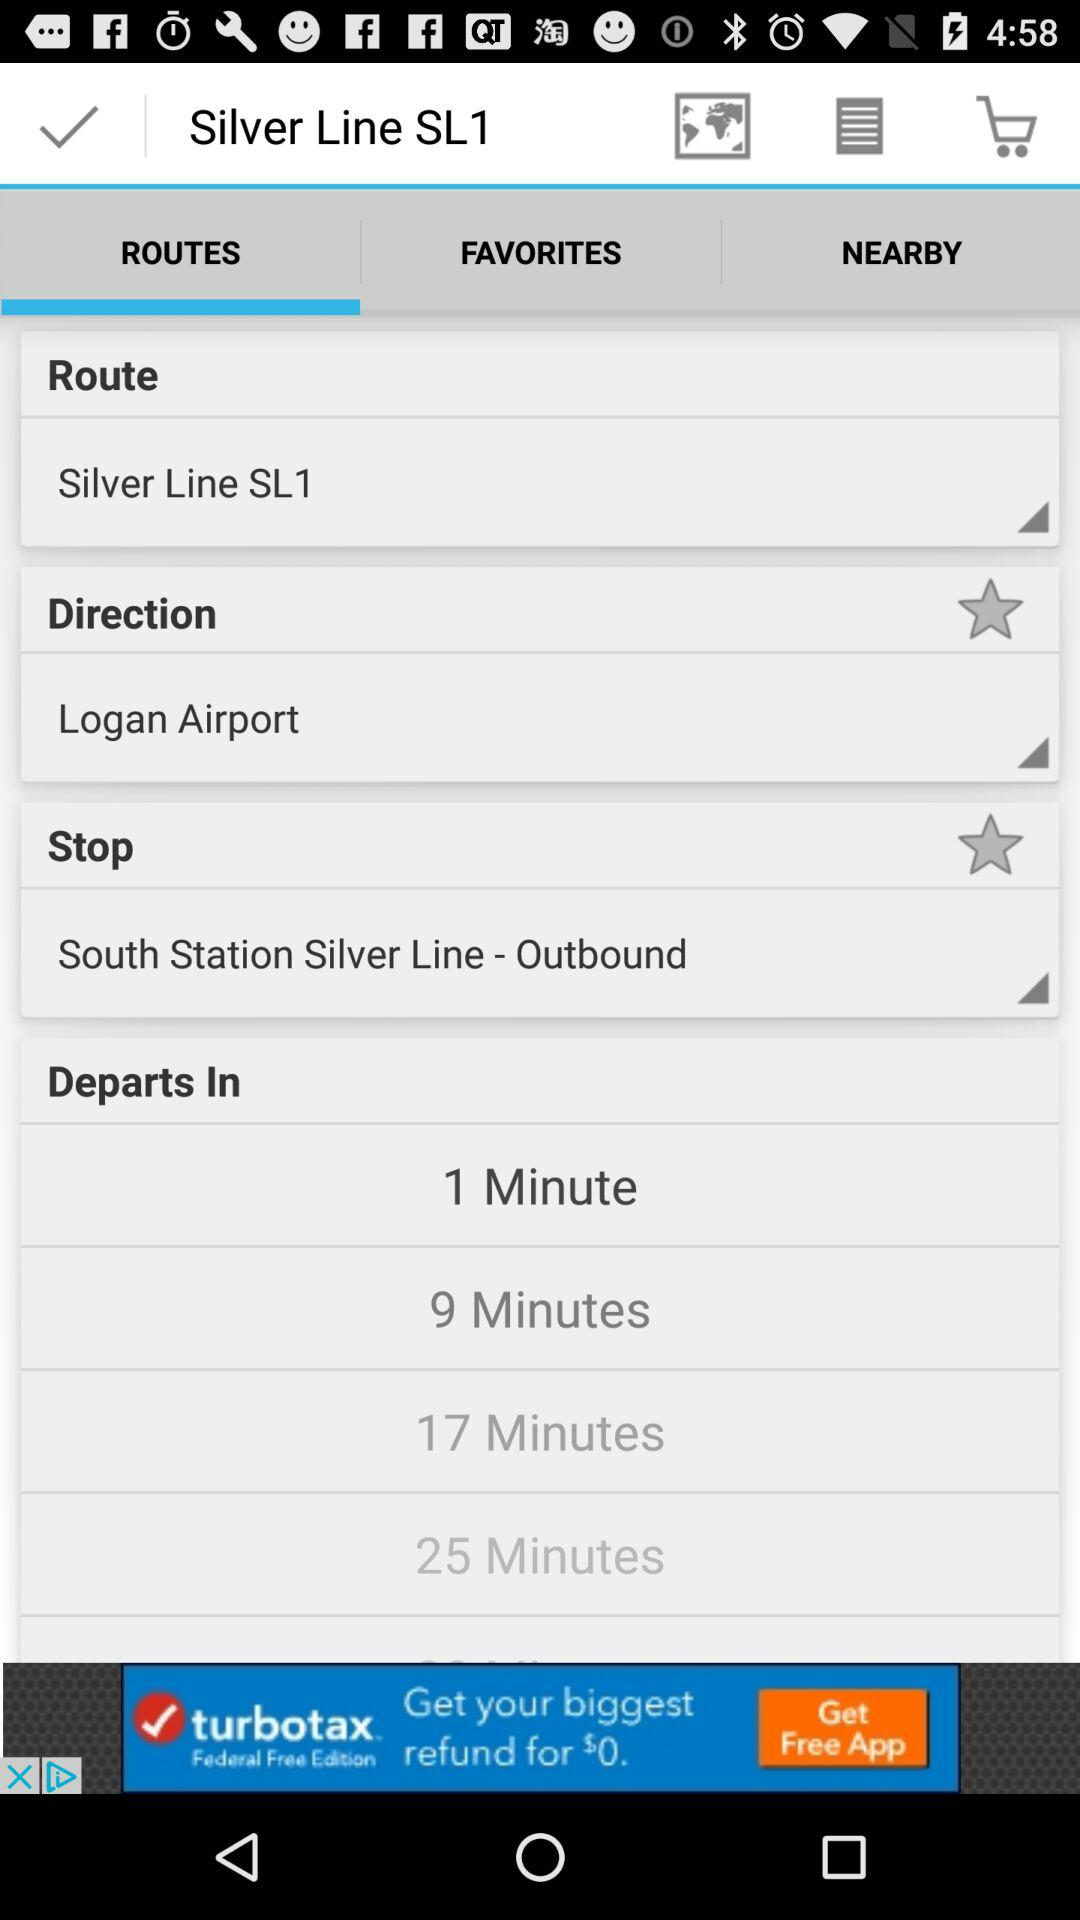How many locations are nearby?
When the provided information is insufficient, respond with <no answer>. <no answer> 